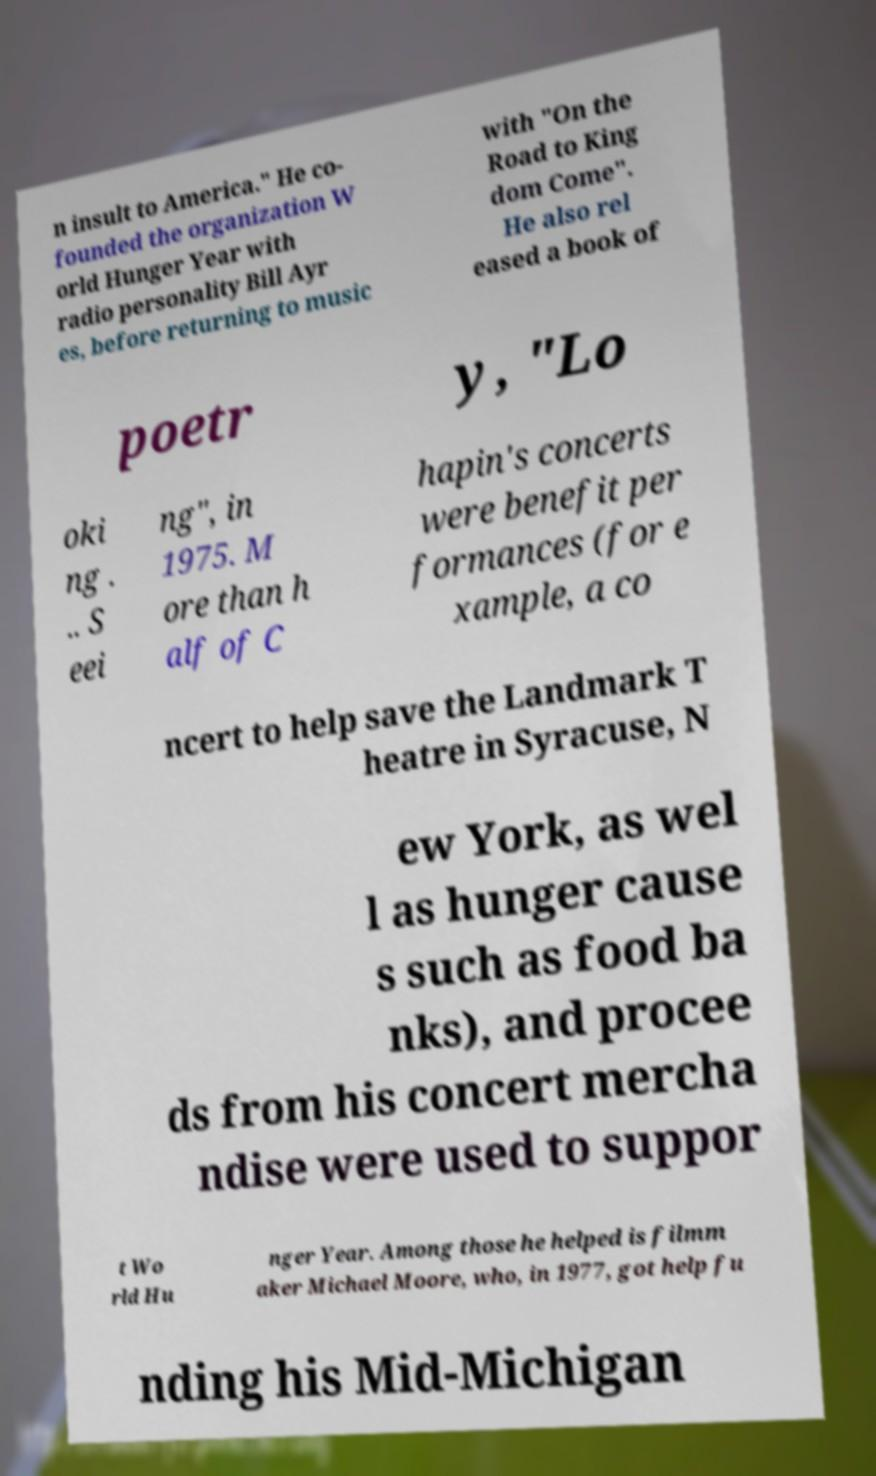I need the written content from this picture converted into text. Can you do that? n insult to America." He co- founded the organization W orld Hunger Year with radio personality Bill Ayr es, before returning to music with "On the Road to King dom Come". He also rel eased a book of poetr y, "Lo oki ng . .. S eei ng", in 1975. M ore than h alf of C hapin's concerts were benefit per formances (for e xample, a co ncert to help save the Landmark T heatre in Syracuse, N ew York, as wel l as hunger cause s such as food ba nks), and procee ds from his concert mercha ndise were used to suppor t Wo rld Hu nger Year. Among those he helped is filmm aker Michael Moore, who, in 1977, got help fu nding his Mid-Michigan 